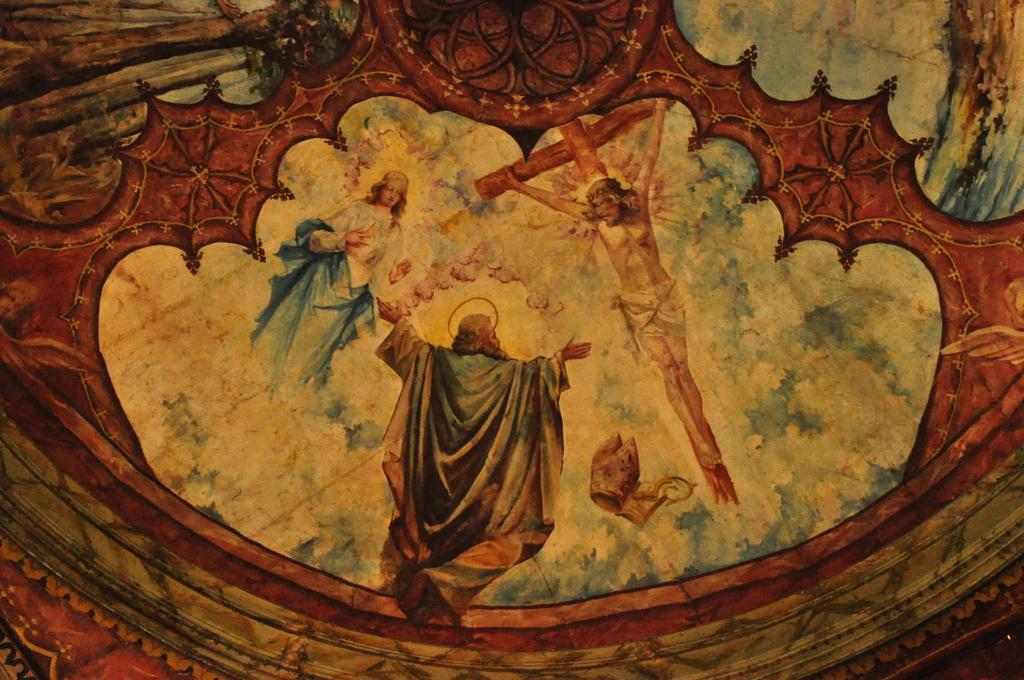What is the main subject of the image? There is a painting in the image. What is happening in the painting? There are people flying in the sky and a person standing on a cross in the painting. How is the sky depicted in the painting? The sky in the painting is cloudy. What type of home can be seen in the painting? There is no home depicted in the painting; it features people flying in the sky and a person standing on a cross. How does the painting provide support for the people flying in the sky? The painting itself does not provide support for the people flying in the sky; it is a two-dimensional representation of the scene. 